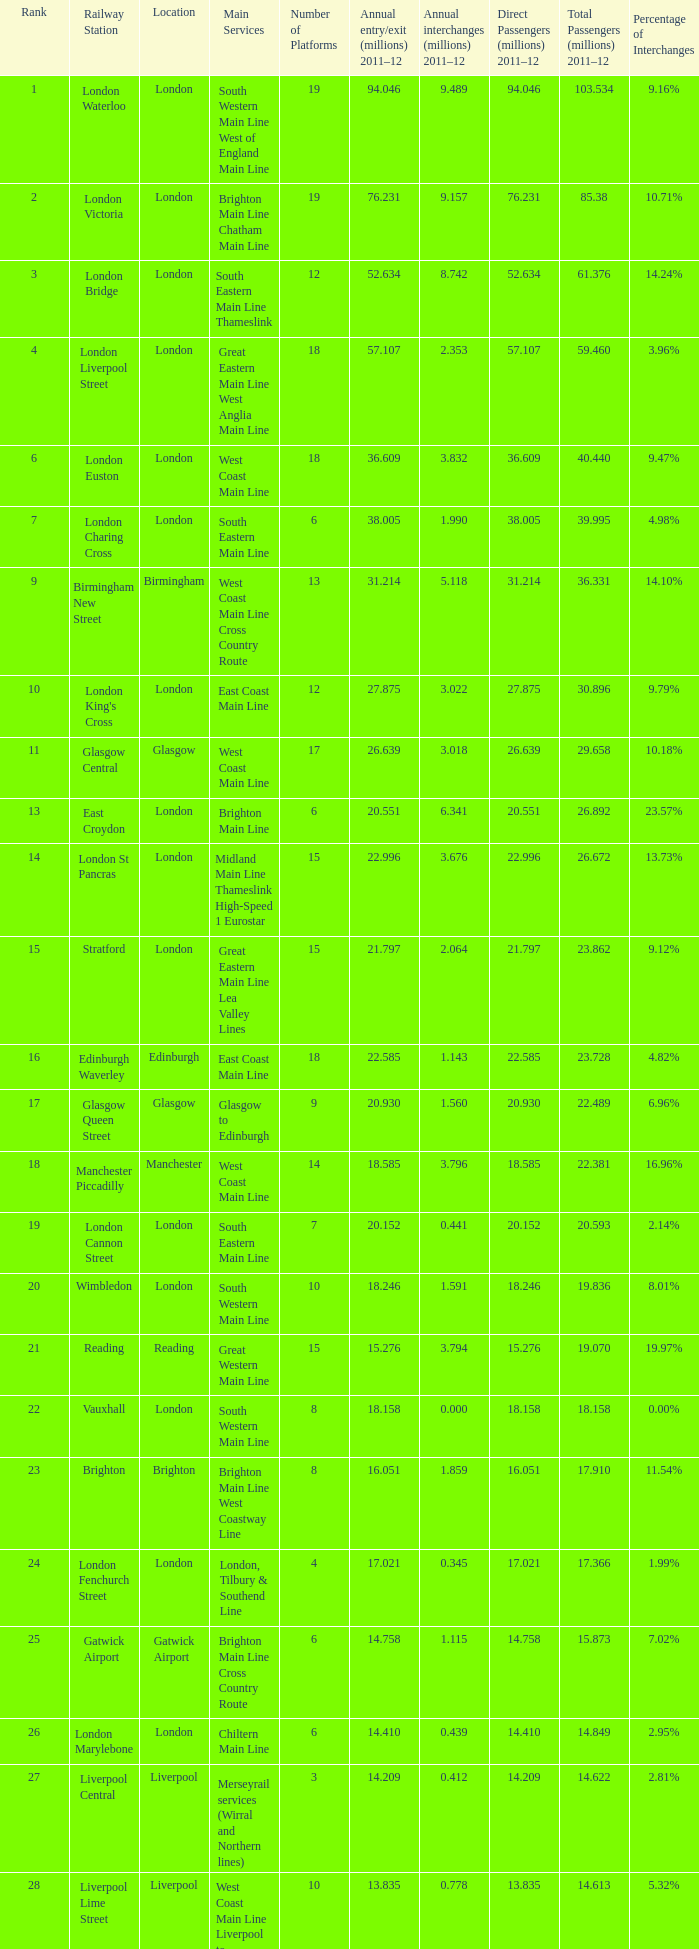What is the lowest rank of Gatwick Airport?  25.0. 